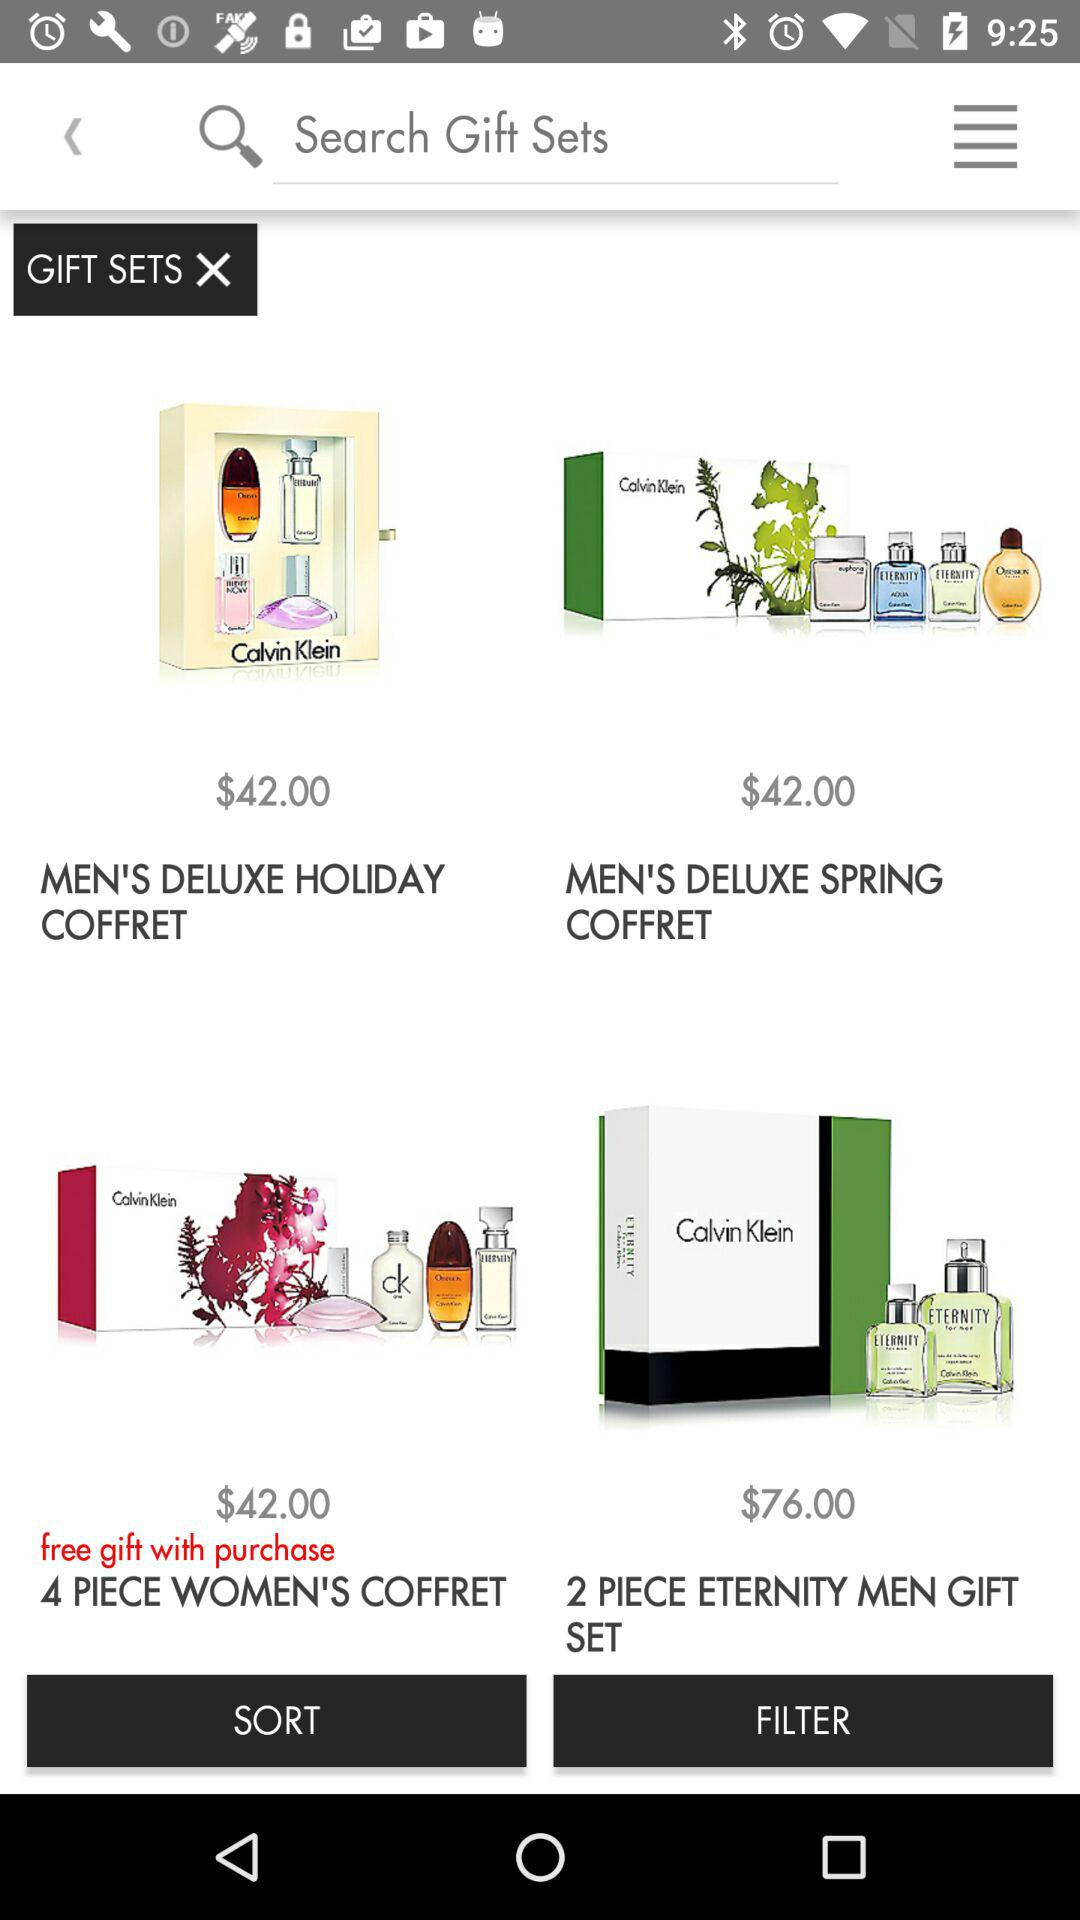Which item has a price of $76? The item is 2 piece eternity men gift set. 